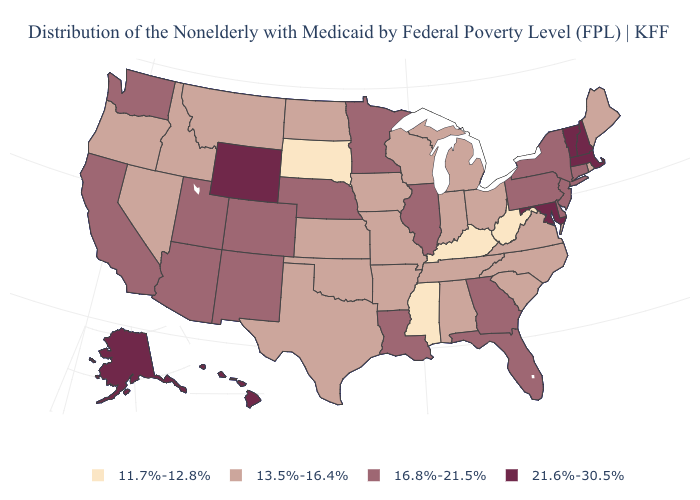Is the legend a continuous bar?
Give a very brief answer. No. Which states have the lowest value in the MidWest?
Write a very short answer. South Dakota. Name the states that have a value in the range 13.5%-16.4%?
Keep it brief. Alabama, Arkansas, Idaho, Indiana, Iowa, Kansas, Maine, Michigan, Missouri, Montana, Nevada, North Carolina, North Dakota, Ohio, Oklahoma, Oregon, Rhode Island, South Carolina, Tennessee, Texas, Virginia, Wisconsin. What is the highest value in the USA?
Quick response, please. 21.6%-30.5%. What is the highest value in states that border Massachusetts?
Keep it brief. 21.6%-30.5%. Which states hav the highest value in the Northeast?
Be succinct. Massachusetts, New Hampshire, Vermont. What is the value of Nebraska?
Give a very brief answer. 16.8%-21.5%. Name the states that have a value in the range 13.5%-16.4%?
Give a very brief answer. Alabama, Arkansas, Idaho, Indiana, Iowa, Kansas, Maine, Michigan, Missouri, Montana, Nevada, North Carolina, North Dakota, Ohio, Oklahoma, Oregon, Rhode Island, South Carolina, Tennessee, Texas, Virginia, Wisconsin. Which states have the highest value in the USA?
Short answer required. Alaska, Hawaii, Maryland, Massachusetts, New Hampshire, Vermont, Wyoming. Name the states that have a value in the range 11.7%-12.8%?
Keep it brief. Kentucky, Mississippi, South Dakota, West Virginia. Among the states that border Nebraska , which have the highest value?
Be succinct. Wyoming. Name the states that have a value in the range 13.5%-16.4%?
Keep it brief. Alabama, Arkansas, Idaho, Indiana, Iowa, Kansas, Maine, Michigan, Missouri, Montana, Nevada, North Carolina, North Dakota, Ohio, Oklahoma, Oregon, Rhode Island, South Carolina, Tennessee, Texas, Virginia, Wisconsin. What is the value of North Carolina?
Be succinct. 13.5%-16.4%. Among the states that border South Carolina , does Georgia have the highest value?
Give a very brief answer. Yes. Among the states that border South Carolina , does Georgia have the highest value?
Keep it brief. Yes. 